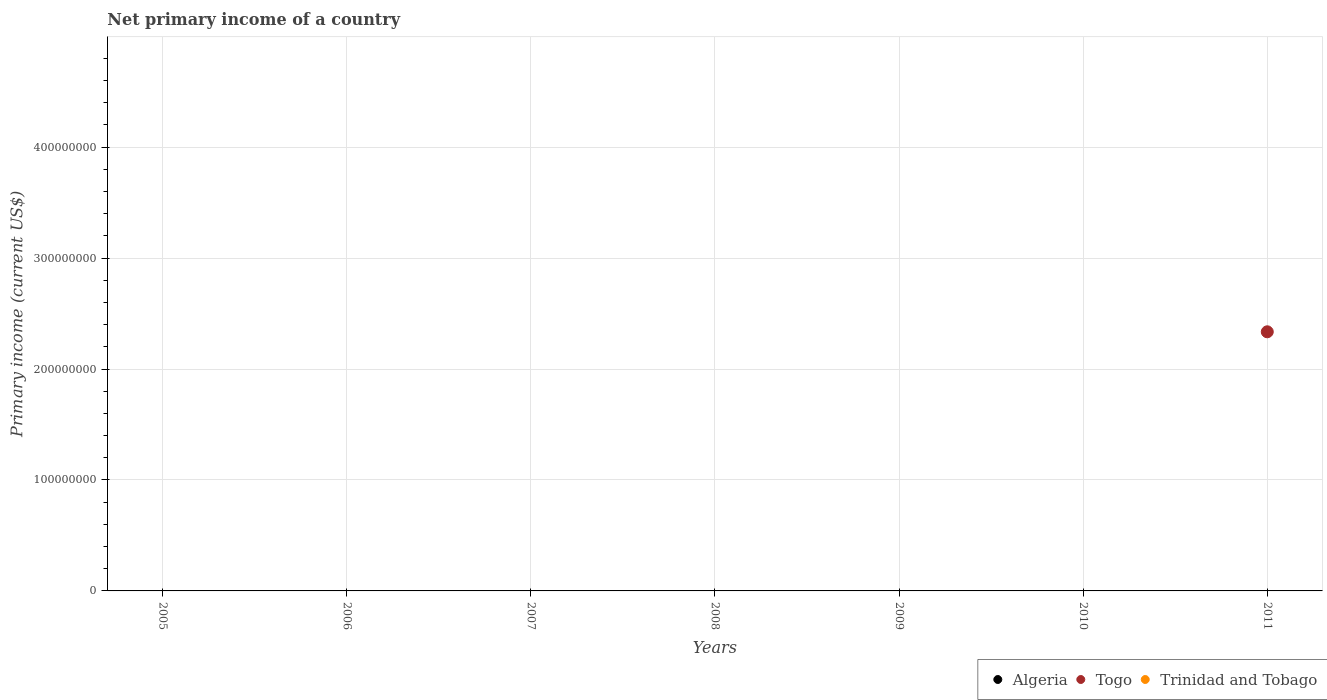How many different coloured dotlines are there?
Provide a succinct answer. 1. Across all years, what is the maximum primary income in Togo?
Offer a very short reply. 2.34e+08. What is the total primary income in Togo in the graph?
Keep it short and to the point. 2.34e+08. What is the average primary income in Togo per year?
Give a very brief answer. 3.34e+07. What is the difference between the highest and the lowest primary income in Togo?
Keep it short and to the point. 2.34e+08. In how many years, is the primary income in Togo greater than the average primary income in Togo taken over all years?
Offer a very short reply. 1. Is it the case that in every year, the sum of the primary income in Togo and primary income in Trinidad and Tobago  is greater than the primary income in Algeria?
Your answer should be compact. No. How many dotlines are there?
Keep it short and to the point. 1. Are the values on the major ticks of Y-axis written in scientific E-notation?
Offer a terse response. No. Does the graph contain grids?
Provide a short and direct response. Yes. What is the title of the graph?
Your answer should be compact. Net primary income of a country. What is the label or title of the Y-axis?
Offer a terse response. Primary income (current US$). What is the Primary income (current US$) of Togo in 2005?
Make the answer very short. 0. What is the Primary income (current US$) of Trinidad and Tobago in 2005?
Offer a terse response. 0. What is the Primary income (current US$) in Togo in 2006?
Ensure brevity in your answer.  0. What is the Primary income (current US$) of Algeria in 2007?
Ensure brevity in your answer.  0. What is the Primary income (current US$) in Togo in 2007?
Give a very brief answer. 0. What is the Primary income (current US$) of Trinidad and Tobago in 2008?
Your answer should be compact. 0. What is the Primary income (current US$) of Algeria in 2009?
Make the answer very short. 0. What is the Primary income (current US$) of Togo in 2009?
Give a very brief answer. 0. What is the Primary income (current US$) in Trinidad and Tobago in 2009?
Give a very brief answer. 0. What is the Primary income (current US$) in Togo in 2010?
Keep it short and to the point. 0. What is the Primary income (current US$) in Togo in 2011?
Give a very brief answer. 2.34e+08. Across all years, what is the maximum Primary income (current US$) in Togo?
Your answer should be compact. 2.34e+08. Across all years, what is the minimum Primary income (current US$) in Togo?
Offer a very short reply. 0. What is the total Primary income (current US$) of Togo in the graph?
Provide a succinct answer. 2.34e+08. What is the total Primary income (current US$) of Trinidad and Tobago in the graph?
Your response must be concise. 0. What is the average Primary income (current US$) of Algeria per year?
Your answer should be very brief. 0. What is the average Primary income (current US$) in Togo per year?
Your answer should be very brief. 3.34e+07. What is the difference between the highest and the lowest Primary income (current US$) of Togo?
Your answer should be compact. 2.34e+08. 